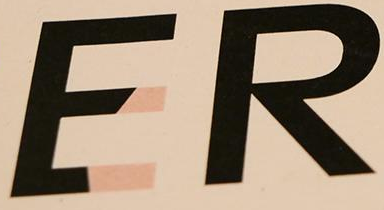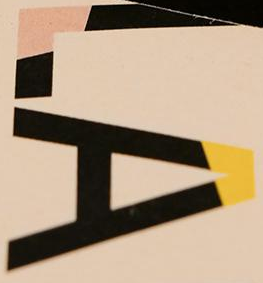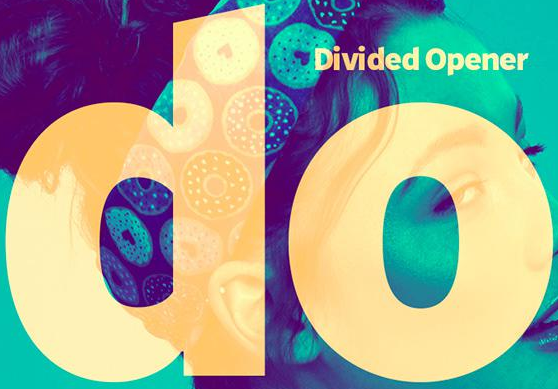Read the text from these images in sequence, separated by a semicolon. ER; LA; do 